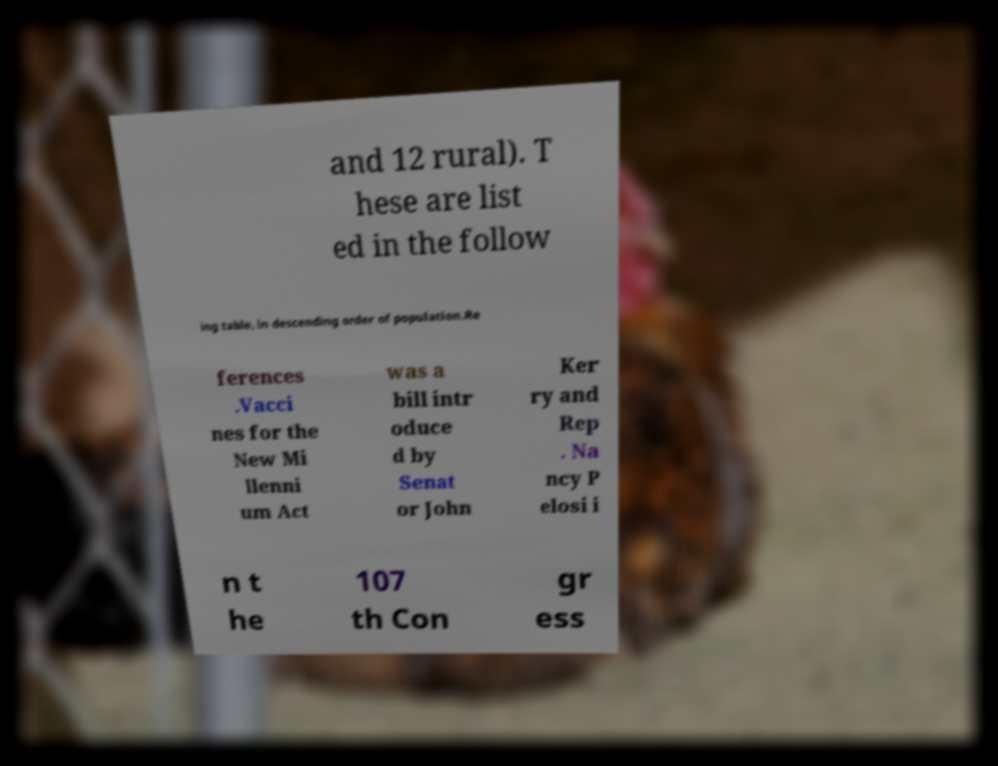What messages or text are displayed in this image? I need them in a readable, typed format. and 12 rural). T hese are list ed in the follow ing table, in descending order of population.Re ferences .Vacci nes for the New Mi llenni um Act was a bill intr oduce d by Senat or John Ker ry and Rep . Na ncy P elosi i n t he 107 th Con gr ess 